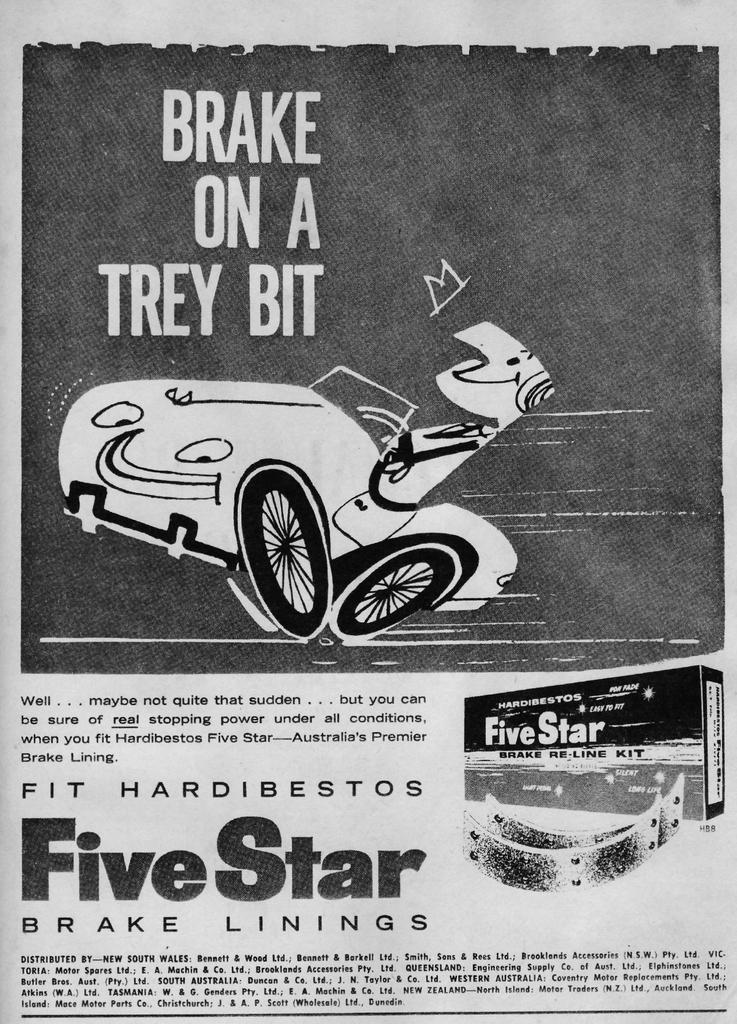What is the main feature of the image's borders? The image has borders, but their specific features are not mentioned in the facts. What is located in the center of the image? There is a paper in the center of the image. What can be found on the paper? Text is printed on the paper. What type of vehicle is depicted in the image? There is a picture of a vehicle in the image. What other object is present in the image? There is a box in the image. Can you describe any other items in the image? There are other items in the image, but their specific details are not mentioned in the facts. What type of chalk is used to draw the vehicle in the image? There is no mention of chalk or drawing in the image; the vehicle is depicted in a picture. What is the name of the person who was born in the image? There is no mention of a birth or a person in the image. 